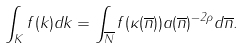<formula> <loc_0><loc_0><loc_500><loc_500>\int _ { K } f ( k ) d k = \int _ { \overline { N } } f ( \kappa ( \overline { n } ) ) a ( \overline { n } ) ^ { - 2 \rho } d \overline { n } .</formula> 